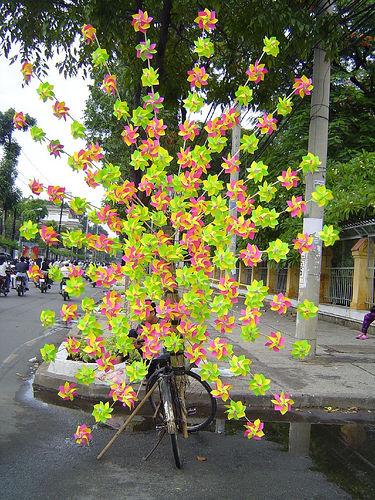What mode of transportation is in the center?
Concise answer only. Bicycle. Is there a person under all these things?
Short answer required. Yes. Outside or inside when this was taken?
Quick response, please. Outside. 